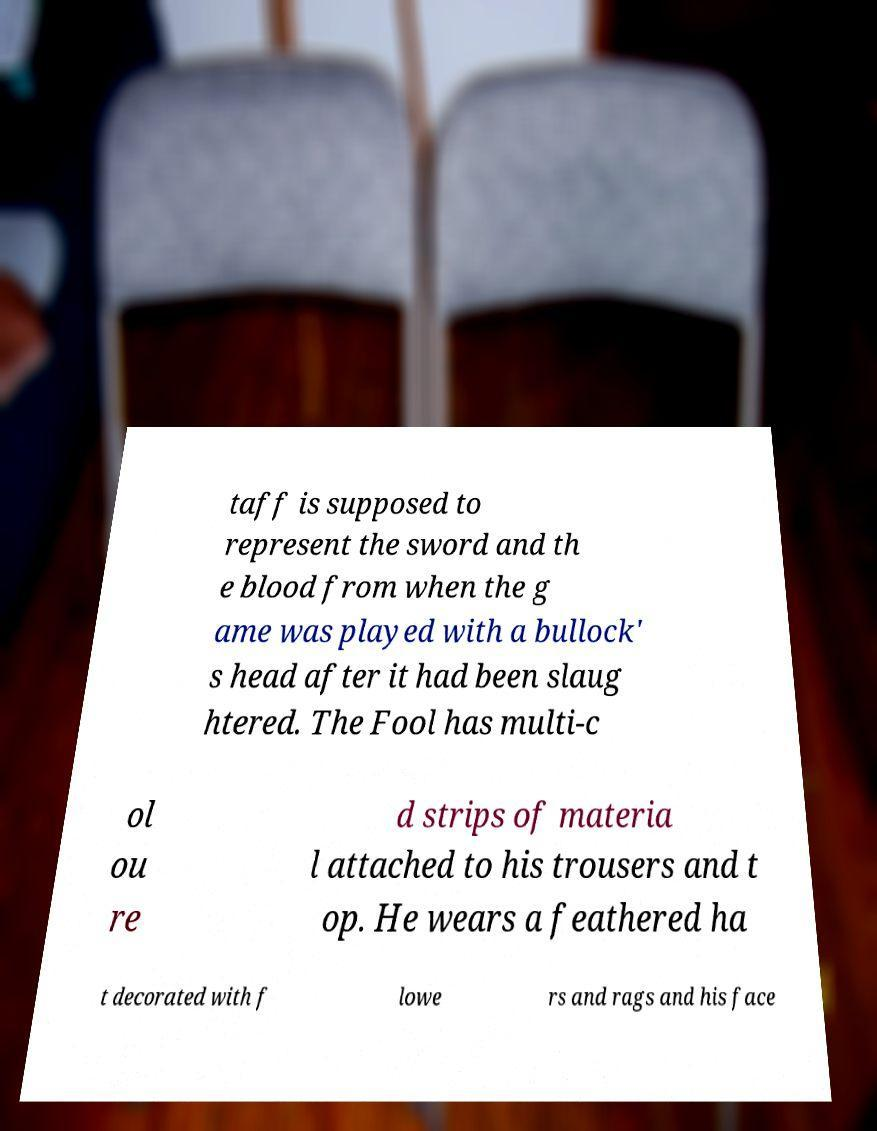What messages or text are displayed in this image? I need them in a readable, typed format. taff is supposed to represent the sword and th e blood from when the g ame was played with a bullock' s head after it had been slaug htered. The Fool has multi-c ol ou re d strips of materia l attached to his trousers and t op. He wears a feathered ha t decorated with f lowe rs and rags and his face 